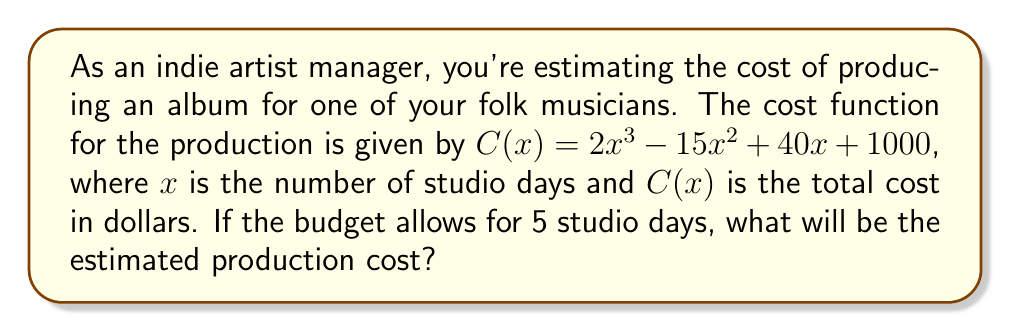Provide a solution to this math problem. To solve this problem, we need to evaluate the cost function $C(x)$ at $x = 5$. Let's break it down step by step:

1) The cost function is $C(x) = 2x^3 - 15x^2 + 40x + 1000$

2) We need to calculate $C(5)$, so let's substitute $x = 5$ into the function:

   $C(5) = 2(5^3) - 15(5^2) + 40(5) + 1000$

3) Let's evaluate each term:
   - $2(5^3) = 2(125) = 250$
   - $15(5^2) = 15(25) = 375$
   - $40(5) = 200$
   - The constant term is already 1000

4) Now, let's combine these terms:

   $C(5) = 250 - 375 + 200 + 1000$

5) Simplifying:

   $C(5) = 1075$

Therefore, the estimated production cost for 5 studio days is $1075.
Answer: $1075 